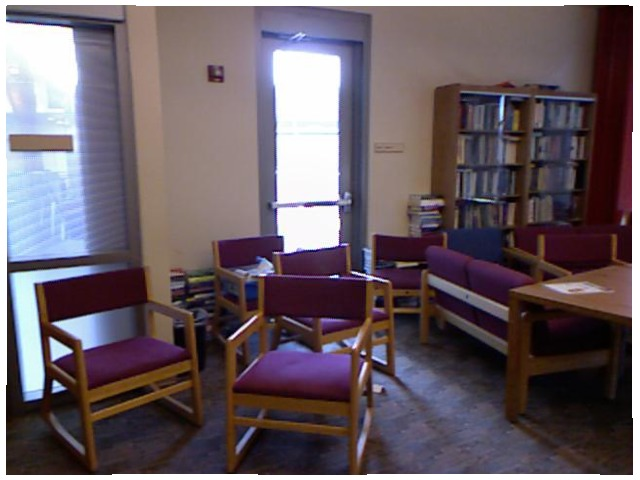<image>
Can you confirm if the chair is on the floor? Yes. Looking at the image, I can see the chair is positioned on top of the floor, with the floor providing support. Where is the table in relation to the chair? Is it on the chair? No. The table is not positioned on the chair. They may be near each other, but the table is not supported by or resting on top of the chair. Is the glass above the chair? No. The glass is not positioned above the chair. The vertical arrangement shows a different relationship. Where is the table in relation to the chair? Is it next to the chair? Yes. The table is positioned adjacent to the chair, located nearby in the same general area. 